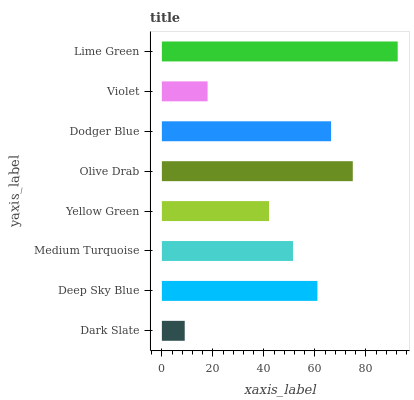Is Dark Slate the minimum?
Answer yes or no. Yes. Is Lime Green the maximum?
Answer yes or no. Yes. Is Deep Sky Blue the minimum?
Answer yes or no. No. Is Deep Sky Blue the maximum?
Answer yes or no. No. Is Deep Sky Blue greater than Dark Slate?
Answer yes or no. Yes. Is Dark Slate less than Deep Sky Blue?
Answer yes or no. Yes. Is Dark Slate greater than Deep Sky Blue?
Answer yes or no. No. Is Deep Sky Blue less than Dark Slate?
Answer yes or no. No. Is Deep Sky Blue the high median?
Answer yes or no. Yes. Is Medium Turquoise the low median?
Answer yes or no. Yes. Is Yellow Green the high median?
Answer yes or no. No. Is Dark Slate the low median?
Answer yes or no. No. 